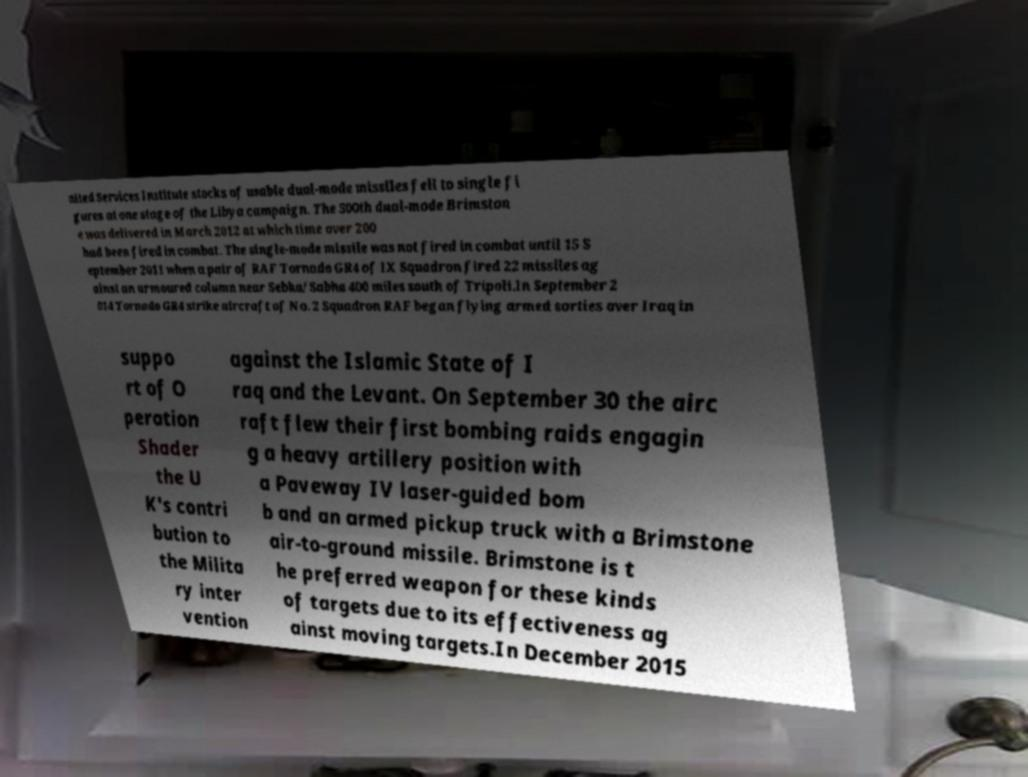What messages or text are displayed in this image? I need them in a readable, typed format. nited Services Institute stocks of usable dual-mode missiles fell to single fi gures at one stage of the Libya campaign. The 500th dual-mode Brimston e was delivered in March 2012 at which time over 200 had been fired in combat. The single-mode missile was not fired in combat until 15 S eptember 2011 when a pair of RAF Tornado GR4 of IX Squadron fired 22 missiles ag ainst an armoured column near Sebha/Sabha 400 miles south of Tripoli.In September 2 014 Tornado GR4 strike aircraft of No. 2 Squadron RAF began flying armed sorties over Iraq in suppo rt of O peration Shader the U K's contri bution to the Milita ry inter vention against the Islamic State of I raq and the Levant. On September 30 the airc raft flew their first bombing raids engagin g a heavy artillery position with a Paveway IV laser-guided bom b and an armed pickup truck with a Brimstone air-to-ground missile. Brimstone is t he preferred weapon for these kinds of targets due to its effectiveness ag ainst moving targets.In December 2015 